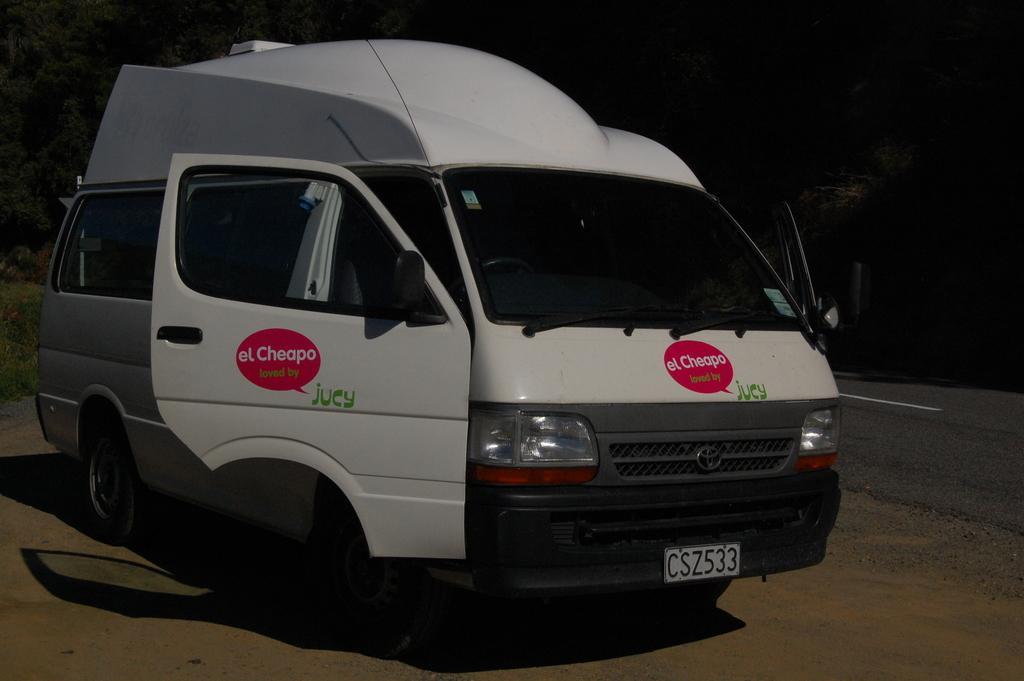What is the main subject in the foreground of the image? There is a vehicle in the foreground of the image. What can be seen on the left side of the image? There are plants on the left side of the image. What is visible in the background of the image? There are trees in the background of the image. What is on the right side of the image? There is a road on the right side of the image. What color of paint is being used to decorate the train in the image? There is no train present in the image; it features a vehicle in the foreground. How many feet are visible on the road in the image? There are no feet visible in the image, as it only shows a vehicle, plants, trees, and a road. 